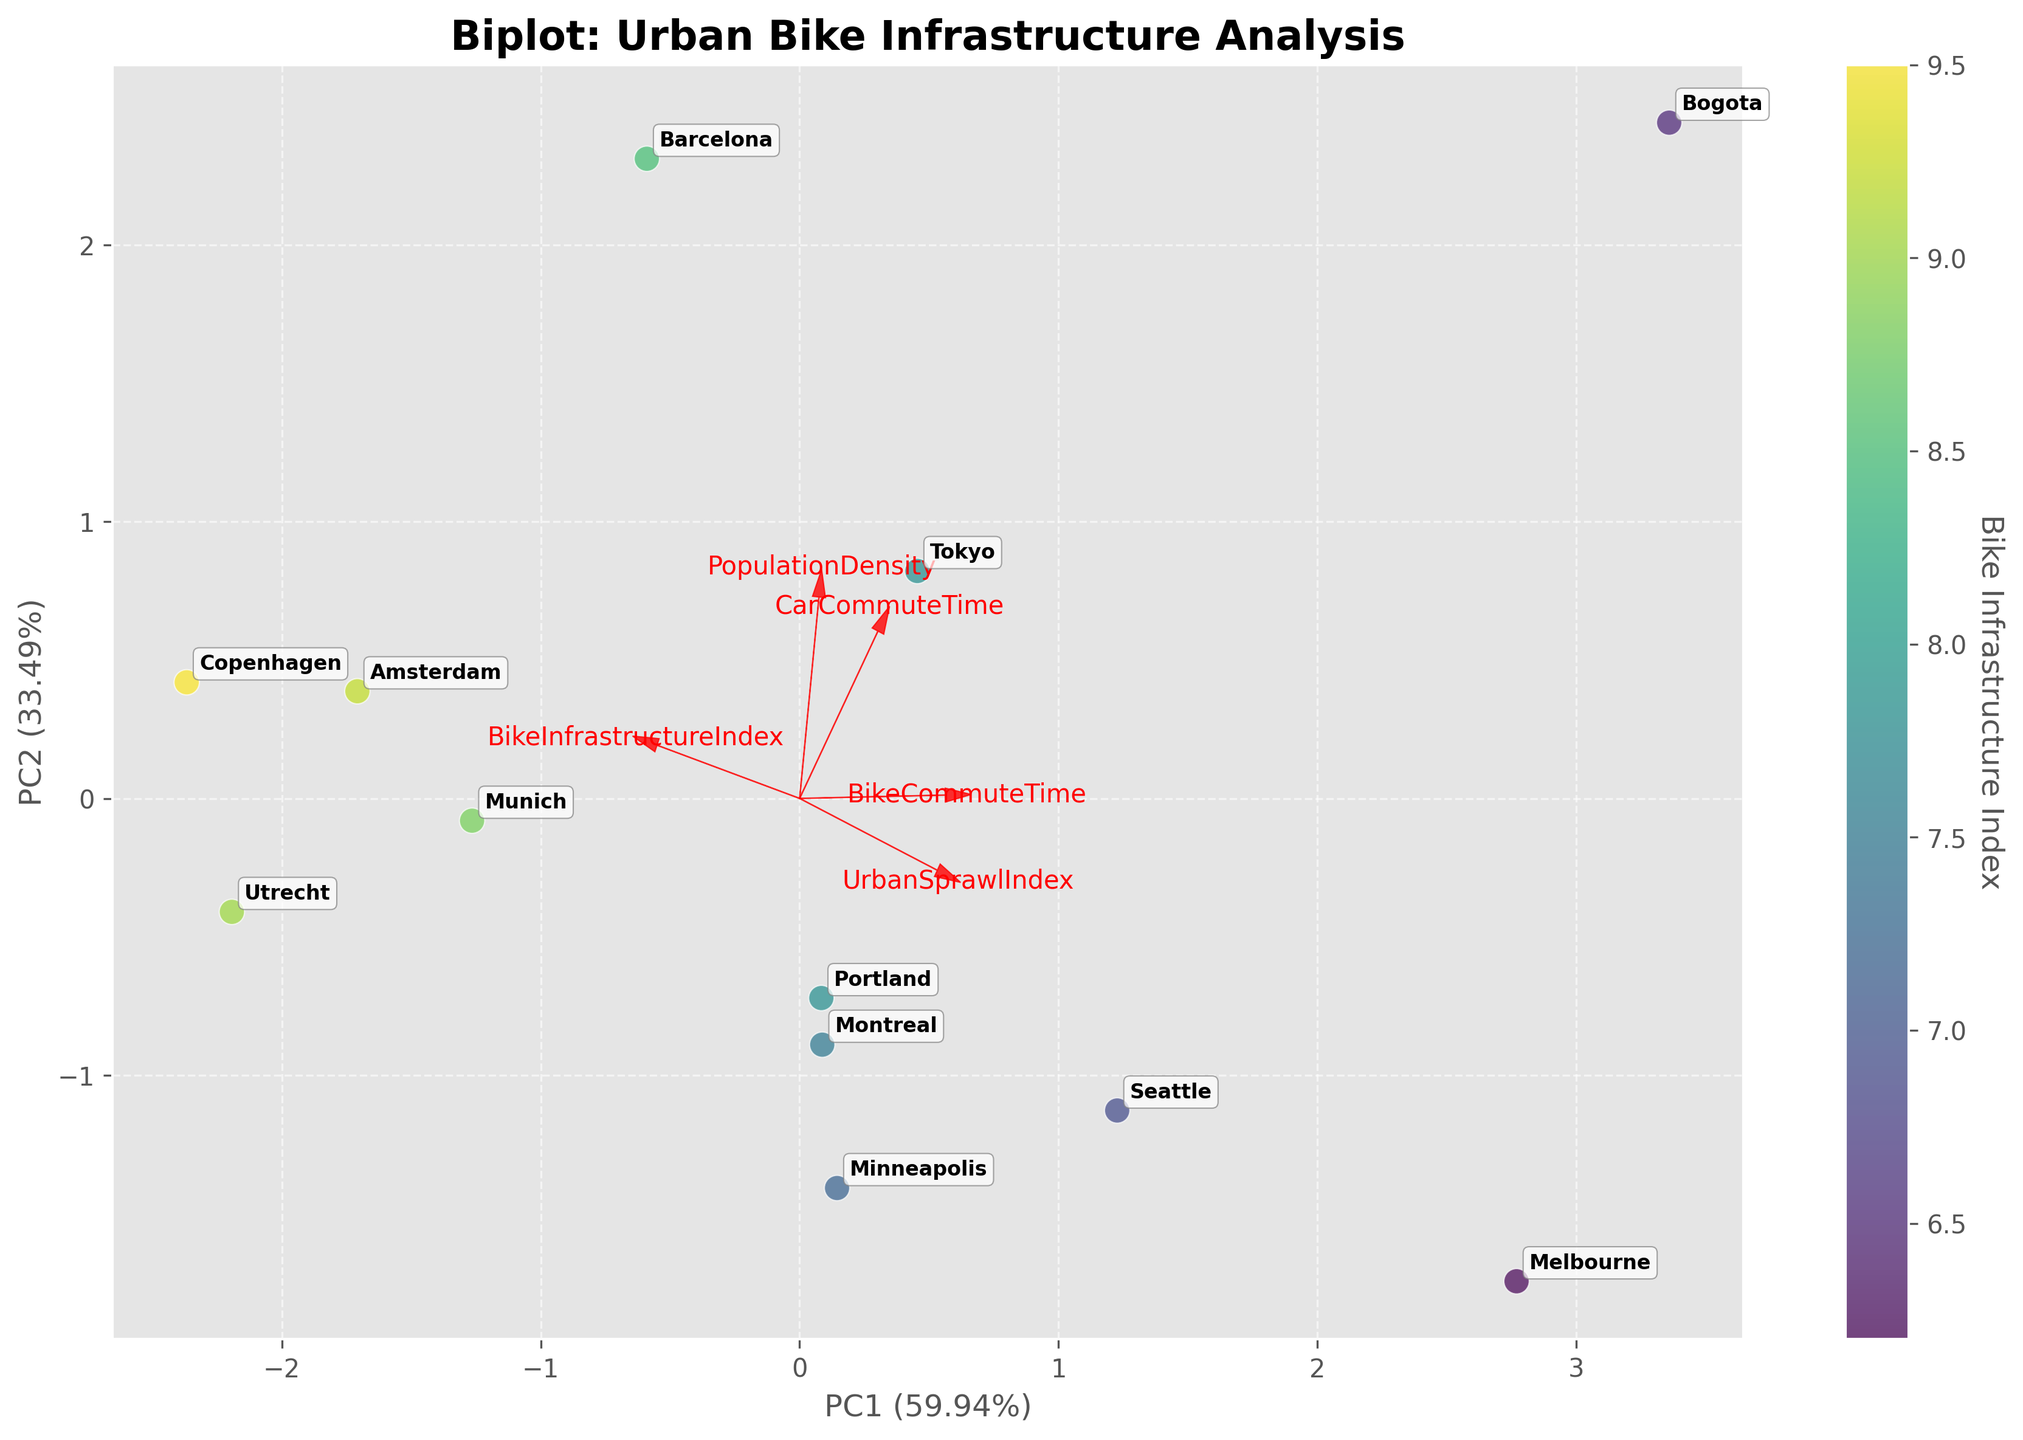What are the names of the cities displayed in the biplot? The cities' names are annotated next to the data points on the plot. They are Amsterdam, Copenhagen, Portland, Minneapolis, Barcelona, Munich, Montreal, Seattle, Utrecht, Bogota, Melbourne, and Tokyo.
Answer: Amsterdam, Copenhagen, Portland, Minneapolis, Barcelona, Munich, Montreal, Seattle, Utrecht, Bogota, Melbourne, Tokyo Which city has the highest Bike Infrastructure Index based on the color gradient of the scatter points? The scatter plot uses a color gradient to represent the Bike Infrastructure Index, with higher values indicated by a darker color in the 'viridis' colormap. As per the plot, Copenhagen appears to have the highest Bike Infrastructure Index, indicated by the darkest color.
Answer: Copenhagen What do the arrows in the biplot represent? The arrows represent the original features in the dataset. The direction and length of each arrow indicate how each feature contributes to the principal components. For example, an arrow pointing in a certain direction shows how a feature aligns with the principal components.
Answer: Original features Which two features contribute the most to the first principal component (PC1)? By examining the lengths and directions of the arrows corresponding to each feature, the features with the longest arrows along the x-axis (PC1) are the ones that contribute the most. BikeCommuteTime and UrbanSprawlIndex have the longest arrows along PC1, indicating the highest contribution.
Answer: BikeCommuteTime, UrbanSprawlIndex Which city has the highest car commute time? Car Commute Time is one of the features visualized in the biplot. The annotation next to the data point farthest along the vector for CarCommuteTime, which is in the positive direction, represents Bogota, indicating it has the highest car commute time.
Answer: Bogota What is the relationship between Population Density and Urban Sprawl Index as indicated by the biplot? The direction and relative lengths of the arrows for Population Density and Urban Sprawl Index indicate if they are positively or negatively correlated. The arrows for these two features point in opposite directions, suggesting a negative correlation between Population Density and Urban Sprawl Index.
Answer: Negatively correlated Which feature seems to be most orthogonal (least correlated) to Bike Infrastructure Index based on the biplot? Features that are orthogonal (perpendicular) to each other are the least correlated. The arrow of PopulationDensity appears roughly orthogonal to the BikeInfrastructureIndex arrow. This indicates that Population Density is least correlated with Bike Infrastructure Index.
Answer: Population Density Explain if there's a city where bike commute time is lower than car commute time. Identify the regions represented by BikeCommuteTime and CarCommuteTime vectors. Then, see which city’s coordinates have a lower value in the direction of the BikeCommuteTime vector compared to the CarCommuteTime vector. Portland's positioning suggests its bike commute time is lower than its car commute time.
Answer: Portland Which principal component accounts for more variance in the data? Look at the labels for the x-axis (PC1) and y-axis (PC2) which indicate the percentage of variance explained by each principal component. PC1 accounts for a higher percentage of variance as indicated by the higher value in its label compared to PC2.
Answer: PC1 What is the cumulative explained variance of the first two principal components? The cumulative explained variance is obtained by summing the variance explained by PC1 and PC2. Refer to the axis labels for the percentage values. Adding both values gives the cumulative explained variance.
Answer: Sum of PC1 and PC2 percentages 